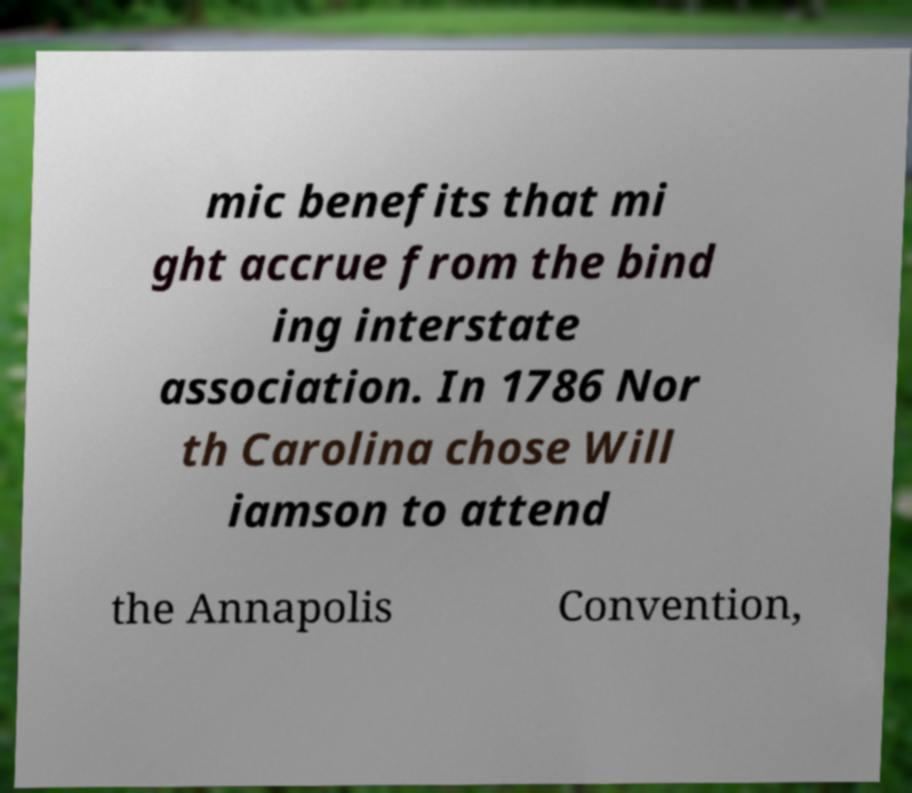Please identify and transcribe the text found in this image. mic benefits that mi ght accrue from the bind ing interstate association. In 1786 Nor th Carolina chose Will iamson to attend the Annapolis Convention, 